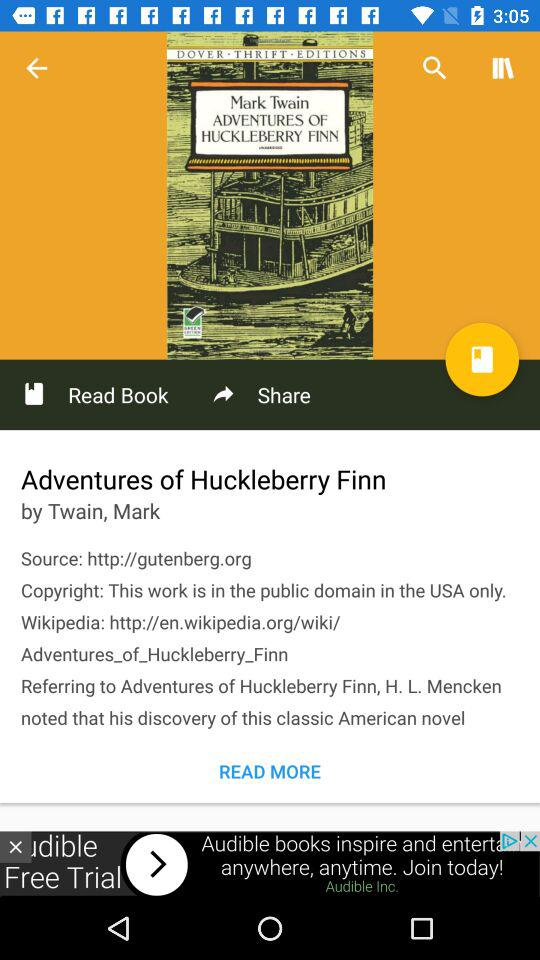What is the name of the book? The name of the book is "Adventures of Huckleberry Finn". 